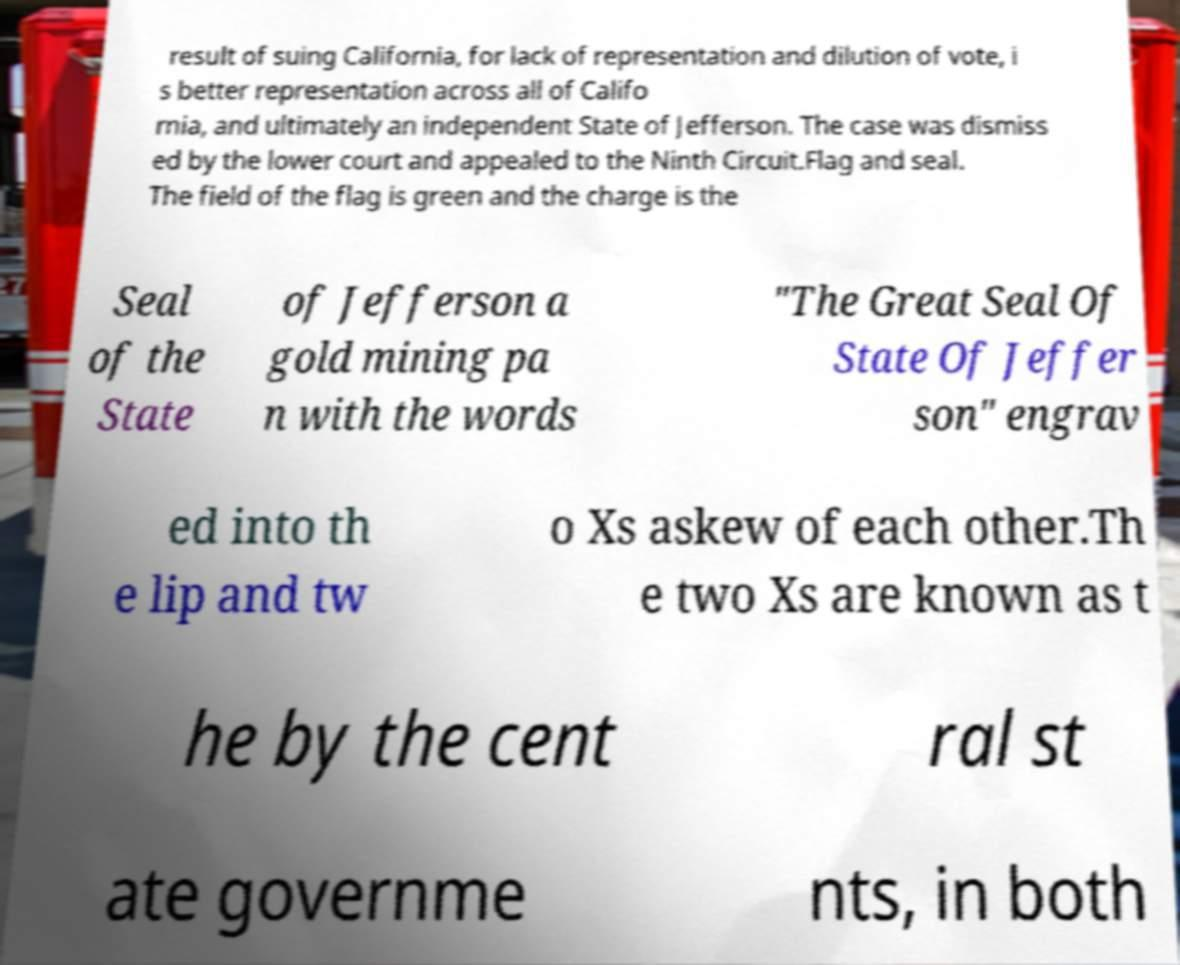For documentation purposes, I need the text within this image transcribed. Could you provide that? result of suing California, for lack of representation and dilution of vote, i s better representation across all of Califo rnia, and ultimately an independent State of Jefferson. The case was dismiss ed by the lower court and appealed to the Ninth Circuit.Flag and seal. The field of the flag is green and the charge is the Seal of the State of Jefferson a gold mining pa n with the words "The Great Seal Of State Of Jeffer son" engrav ed into th e lip and tw o Xs askew of each other.Th e two Xs are known as t he by the cent ral st ate governme nts, in both 